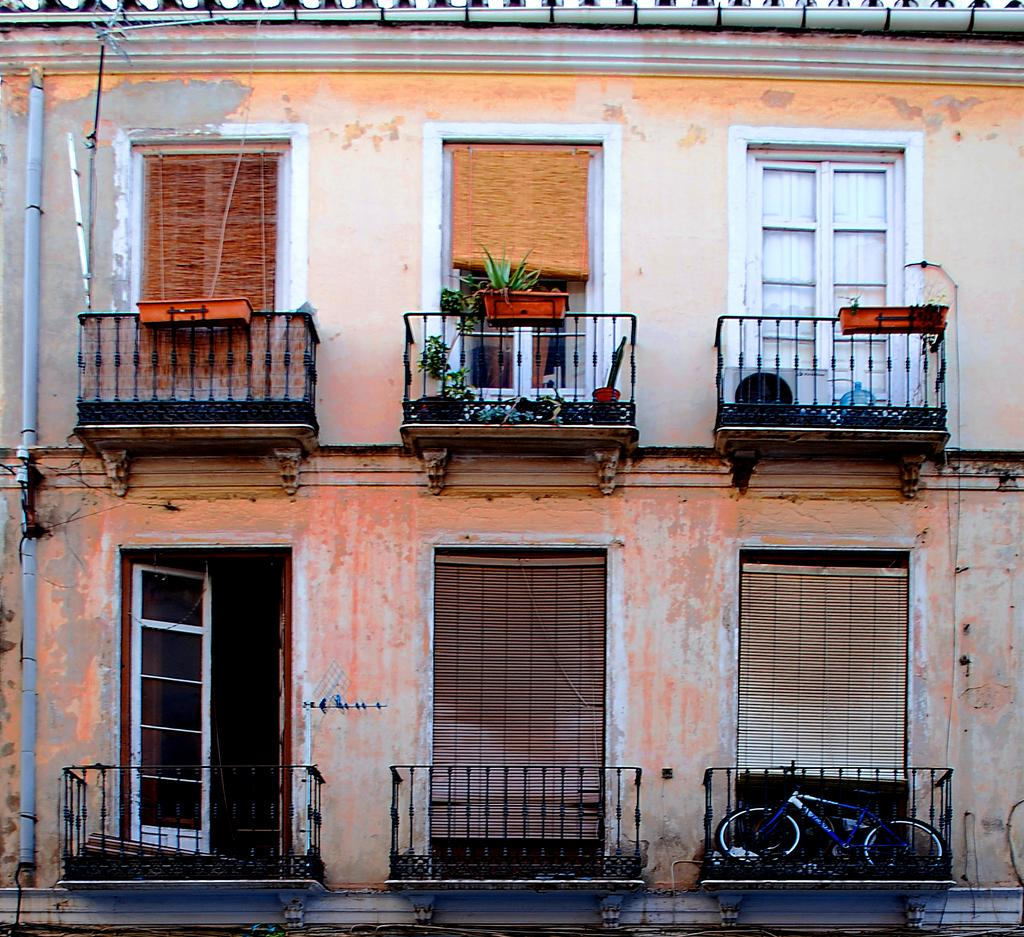What type of structure is in the image? There is a building in the image. What feature can be seen on the building? The building has windows. What might be used to control the amount of light entering the building? Window blinds are present in the image. What type of greenery is in the image? There are potted plants in the image. What architectural element is visible in the image? A grille is visible in the image. What is the tallest structure in the image? There is a pole in the image. What mode of transportation is present in the image? A bicycle is present in the image. What type of shoe can be seen on the building in the image? There is no shoe present on the building in the image. 